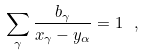Convert formula to latex. <formula><loc_0><loc_0><loc_500><loc_500>\sum _ { \gamma } \frac { b _ { \gamma } } { x _ { \gamma } - y _ { \alpha } } = 1 \ ,</formula> 